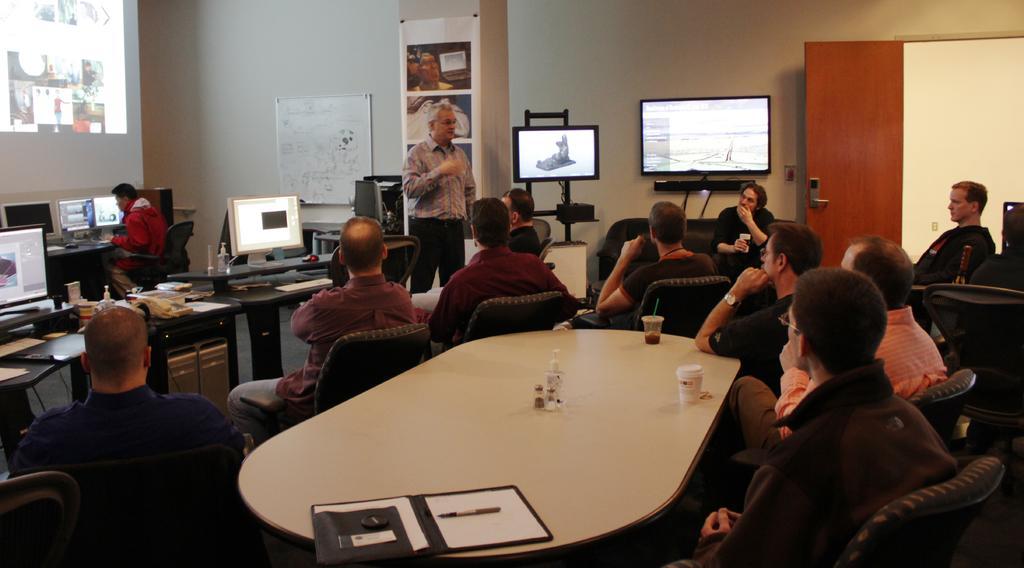In one or two sentences, can you explain what this image depicts? As we can see in the image, there is a white color wall, screen, board, laptops on table and there are few people sitting on chairs. 